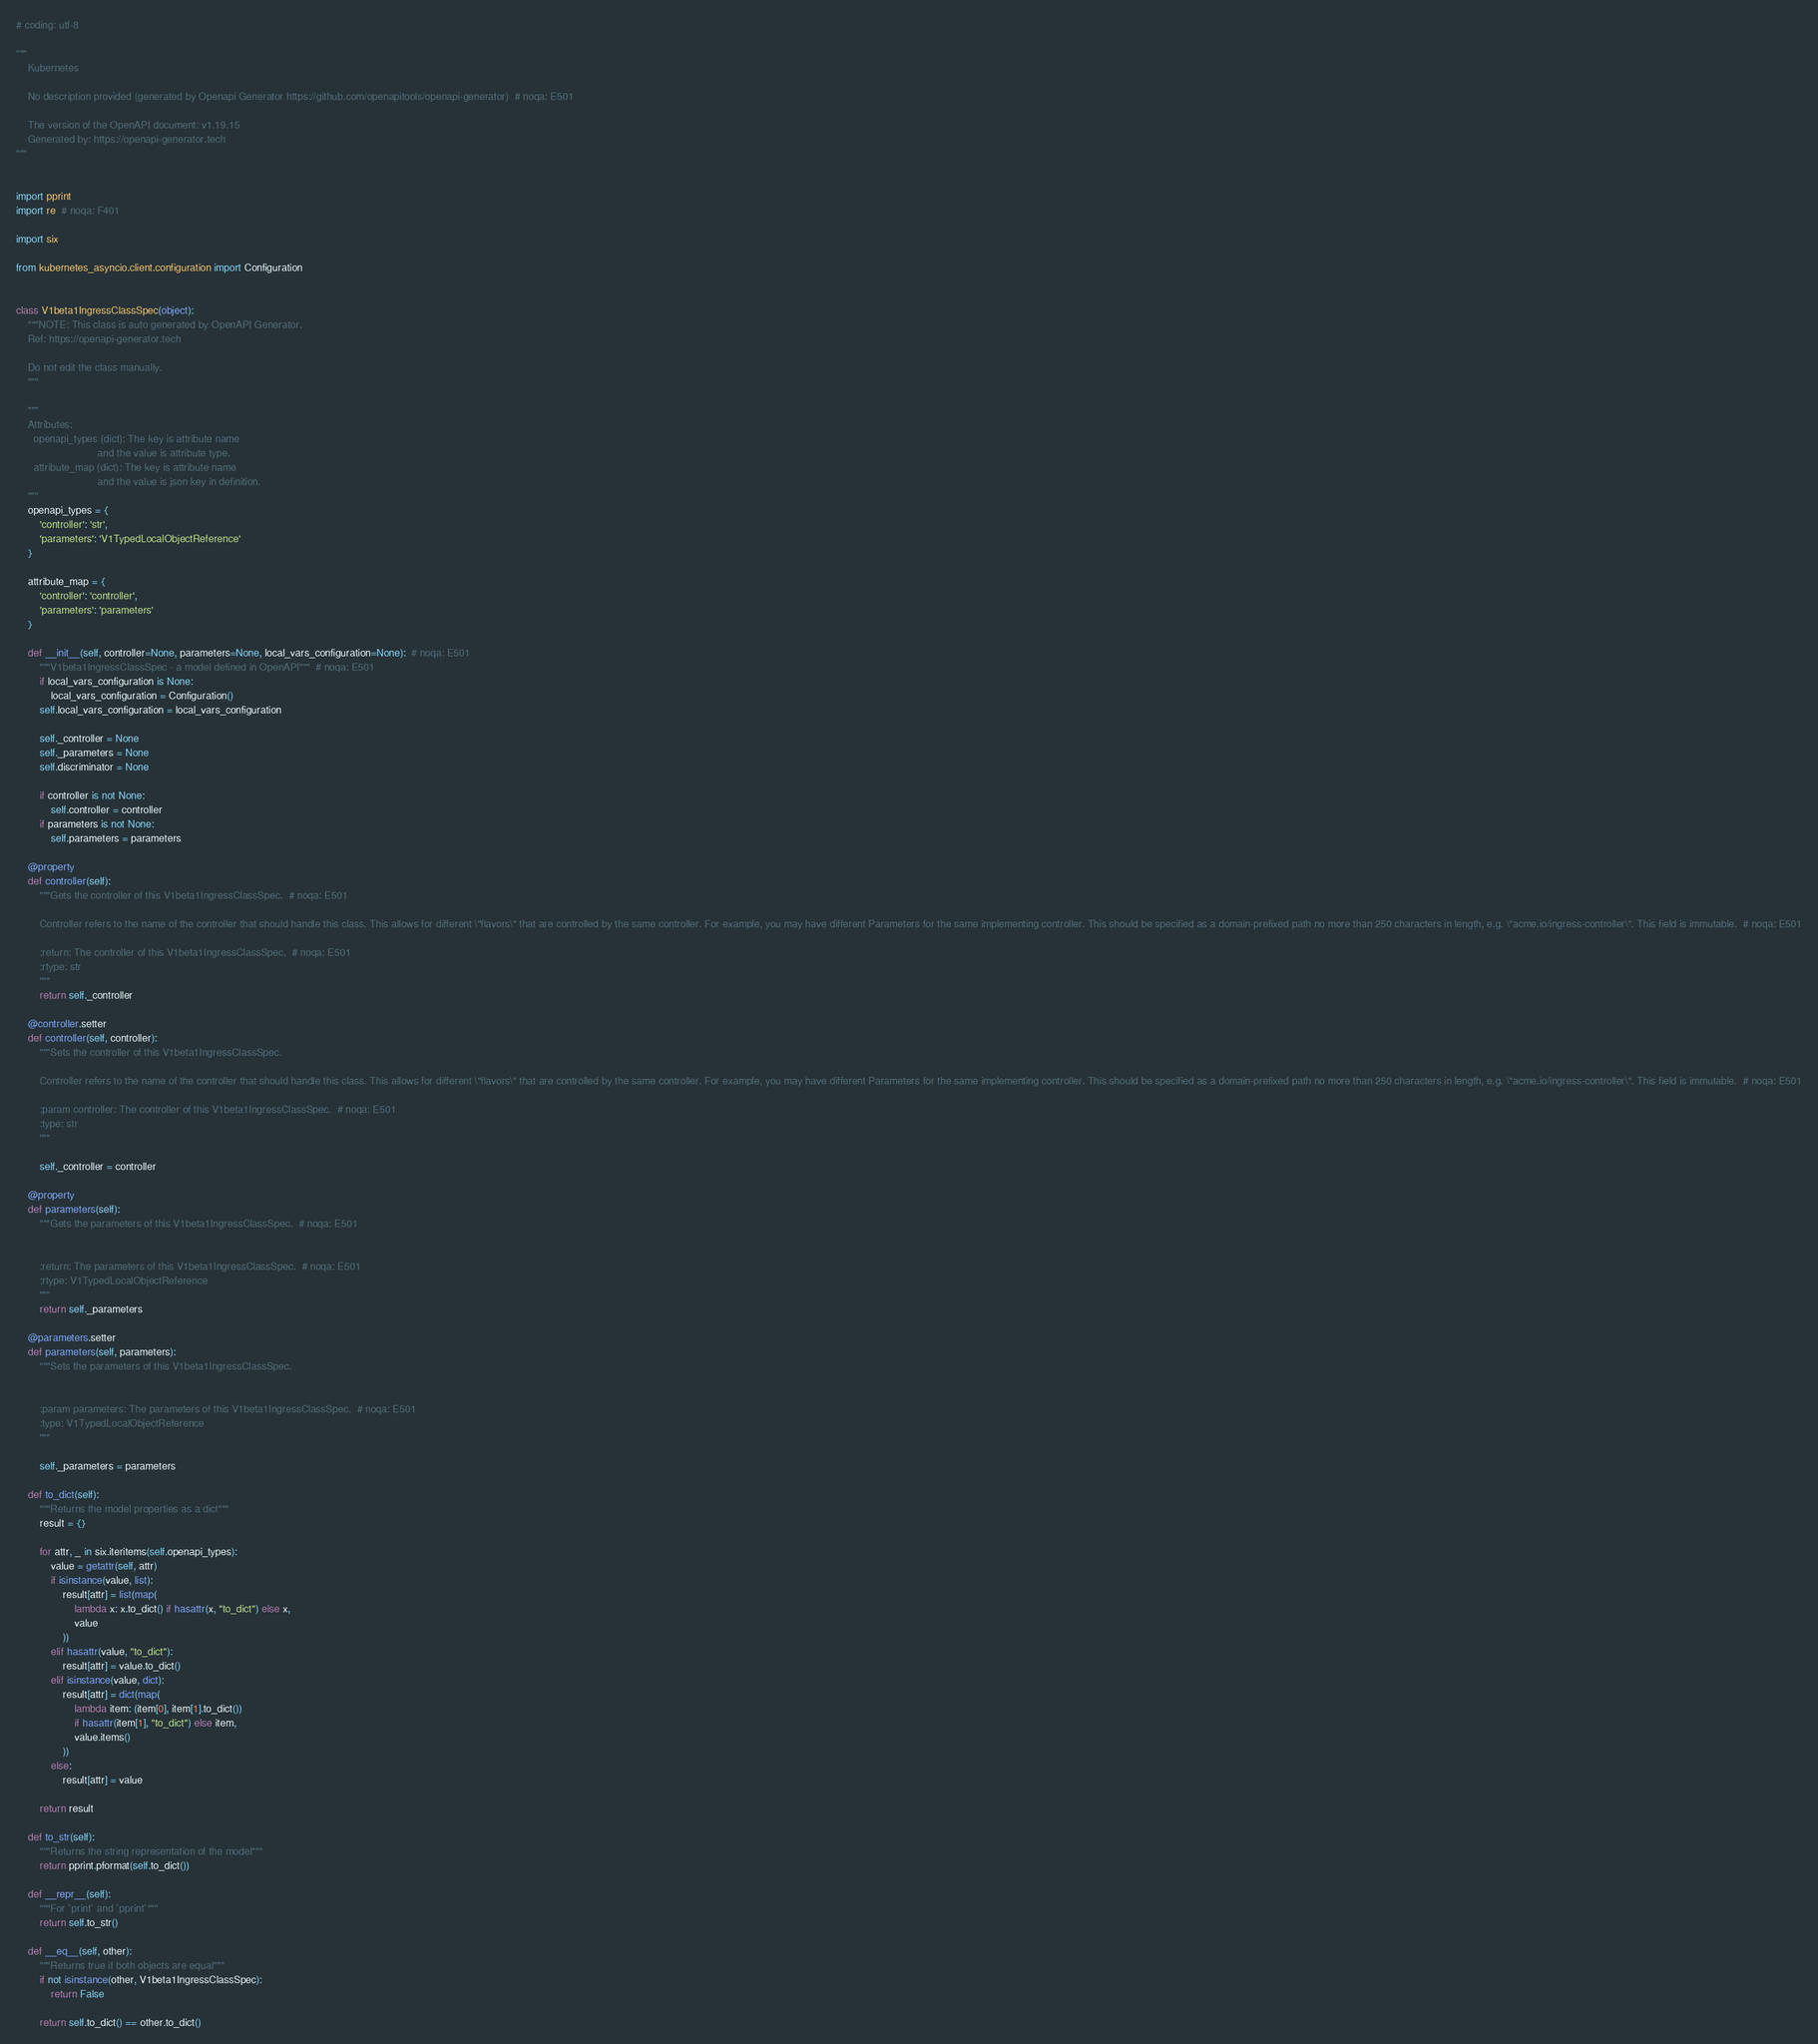Convert code to text. <code><loc_0><loc_0><loc_500><loc_500><_Python_># coding: utf-8

"""
    Kubernetes

    No description provided (generated by Openapi Generator https://github.com/openapitools/openapi-generator)  # noqa: E501

    The version of the OpenAPI document: v1.19.15
    Generated by: https://openapi-generator.tech
"""


import pprint
import re  # noqa: F401

import six

from kubernetes_asyncio.client.configuration import Configuration


class V1beta1IngressClassSpec(object):
    """NOTE: This class is auto generated by OpenAPI Generator.
    Ref: https://openapi-generator.tech

    Do not edit the class manually.
    """

    """
    Attributes:
      openapi_types (dict): The key is attribute name
                            and the value is attribute type.
      attribute_map (dict): The key is attribute name
                            and the value is json key in definition.
    """
    openapi_types = {
        'controller': 'str',
        'parameters': 'V1TypedLocalObjectReference'
    }

    attribute_map = {
        'controller': 'controller',
        'parameters': 'parameters'
    }

    def __init__(self, controller=None, parameters=None, local_vars_configuration=None):  # noqa: E501
        """V1beta1IngressClassSpec - a model defined in OpenAPI"""  # noqa: E501
        if local_vars_configuration is None:
            local_vars_configuration = Configuration()
        self.local_vars_configuration = local_vars_configuration

        self._controller = None
        self._parameters = None
        self.discriminator = None

        if controller is not None:
            self.controller = controller
        if parameters is not None:
            self.parameters = parameters

    @property
    def controller(self):
        """Gets the controller of this V1beta1IngressClassSpec.  # noqa: E501

        Controller refers to the name of the controller that should handle this class. This allows for different \"flavors\" that are controlled by the same controller. For example, you may have different Parameters for the same implementing controller. This should be specified as a domain-prefixed path no more than 250 characters in length, e.g. \"acme.io/ingress-controller\". This field is immutable.  # noqa: E501

        :return: The controller of this V1beta1IngressClassSpec.  # noqa: E501
        :rtype: str
        """
        return self._controller

    @controller.setter
    def controller(self, controller):
        """Sets the controller of this V1beta1IngressClassSpec.

        Controller refers to the name of the controller that should handle this class. This allows for different \"flavors\" that are controlled by the same controller. For example, you may have different Parameters for the same implementing controller. This should be specified as a domain-prefixed path no more than 250 characters in length, e.g. \"acme.io/ingress-controller\". This field is immutable.  # noqa: E501

        :param controller: The controller of this V1beta1IngressClassSpec.  # noqa: E501
        :type: str
        """

        self._controller = controller

    @property
    def parameters(self):
        """Gets the parameters of this V1beta1IngressClassSpec.  # noqa: E501


        :return: The parameters of this V1beta1IngressClassSpec.  # noqa: E501
        :rtype: V1TypedLocalObjectReference
        """
        return self._parameters

    @parameters.setter
    def parameters(self, parameters):
        """Sets the parameters of this V1beta1IngressClassSpec.


        :param parameters: The parameters of this V1beta1IngressClassSpec.  # noqa: E501
        :type: V1TypedLocalObjectReference
        """

        self._parameters = parameters

    def to_dict(self):
        """Returns the model properties as a dict"""
        result = {}

        for attr, _ in six.iteritems(self.openapi_types):
            value = getattr(self, attr)
            if isinstance(value, list):
                result[attr] = list(map(
                    lambda x: x.to_dict() if hasattr(x, "to_dict") else x,
                    value
                ))
            elif hasattr(value, "to_dict"):
                result[attr] = value.to_dict()
            elif isinstance(value, dict):
                result[attr] = dict(map(
                    lambda item: (item[0], item[1].to_dict())
                    if hasattr(item[1], "to_dict") else item,
                    value.items()
                ))
            else:
                result[attr] = value

        return result

    def to_str(self):
        """Returns the string representation of the model"""
        return pprint.pformat(self.to_dict())

    def __repr__(self):
        """For `print` and `pprint`"""
        return self.to_str()

    def __eq__(self, other):
        """Returns true if both objects are equal"""
        if not isinstance(other, V1beta1IngressClassSpec):
            return False

        return self.to_dict() == other.to_dict()
</code> 